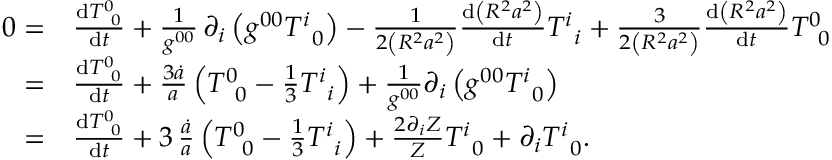Convert formula to latex. <formula><loc_0><loc_0><loc_500><loc_500>\begin{array} { r l } { 0 = } & \frac { d T _ { \, 0 } ^ { 0 } } { d t } + \frac { 1 } { g ^ { 0 0 } } \, \partial _ { i } \left ( g ^ { 0 0 } T _ { \, 0 } ^ { i } \right ) - \frac { 1 } { 2 \left ( R ^ { 2 } a ^ { 2 } \right ) } \frac { d \left ( R ^ { 2 } a ^ { 2 } \right ) } { d t } T _ { \, i } ^ { i } + \frac { 3 } { 2 \left ( R ^ { 2 } a ^ { 2 } \right ) } \frac { d \left ( R ^ { 2 } a ^ { 2 } \right ) } { d t } T _ { \, 0 } ^ { 0 } } \\ { = } & \frac { d T _ { \, 0 } ^ { 0 } } { d t } + \frac { 3 \dot { a } } { a } \left ( T _ { \, 0 } ^ { 0 } - \frac { 1 } { 3 } T _ { \, i } ^ { i } \right ) + \frac { 1 } { g ^ { 0 0 } } \partial _ { i } \left ( g ^ { 0 0 } T _ { \, 0 } ^ { i } \right ) } \\ { = } & \frac { d T _ { \, 0 } ^ { 0 } } { d t } + 3 \, \frac { \dot { a } } { a } \left ( T _ { \, 0 } ^ { 0 } - \frac { 1 } { 3 } T _ { \, i } ^ { i } \right ) + \frac { 2 \partial _ { i } Z } { Z } T _ { \, 0 } ^ { i } + \partial _ { i } T _ { \, 0 } ^ { i } . } \end{array}</formula> 